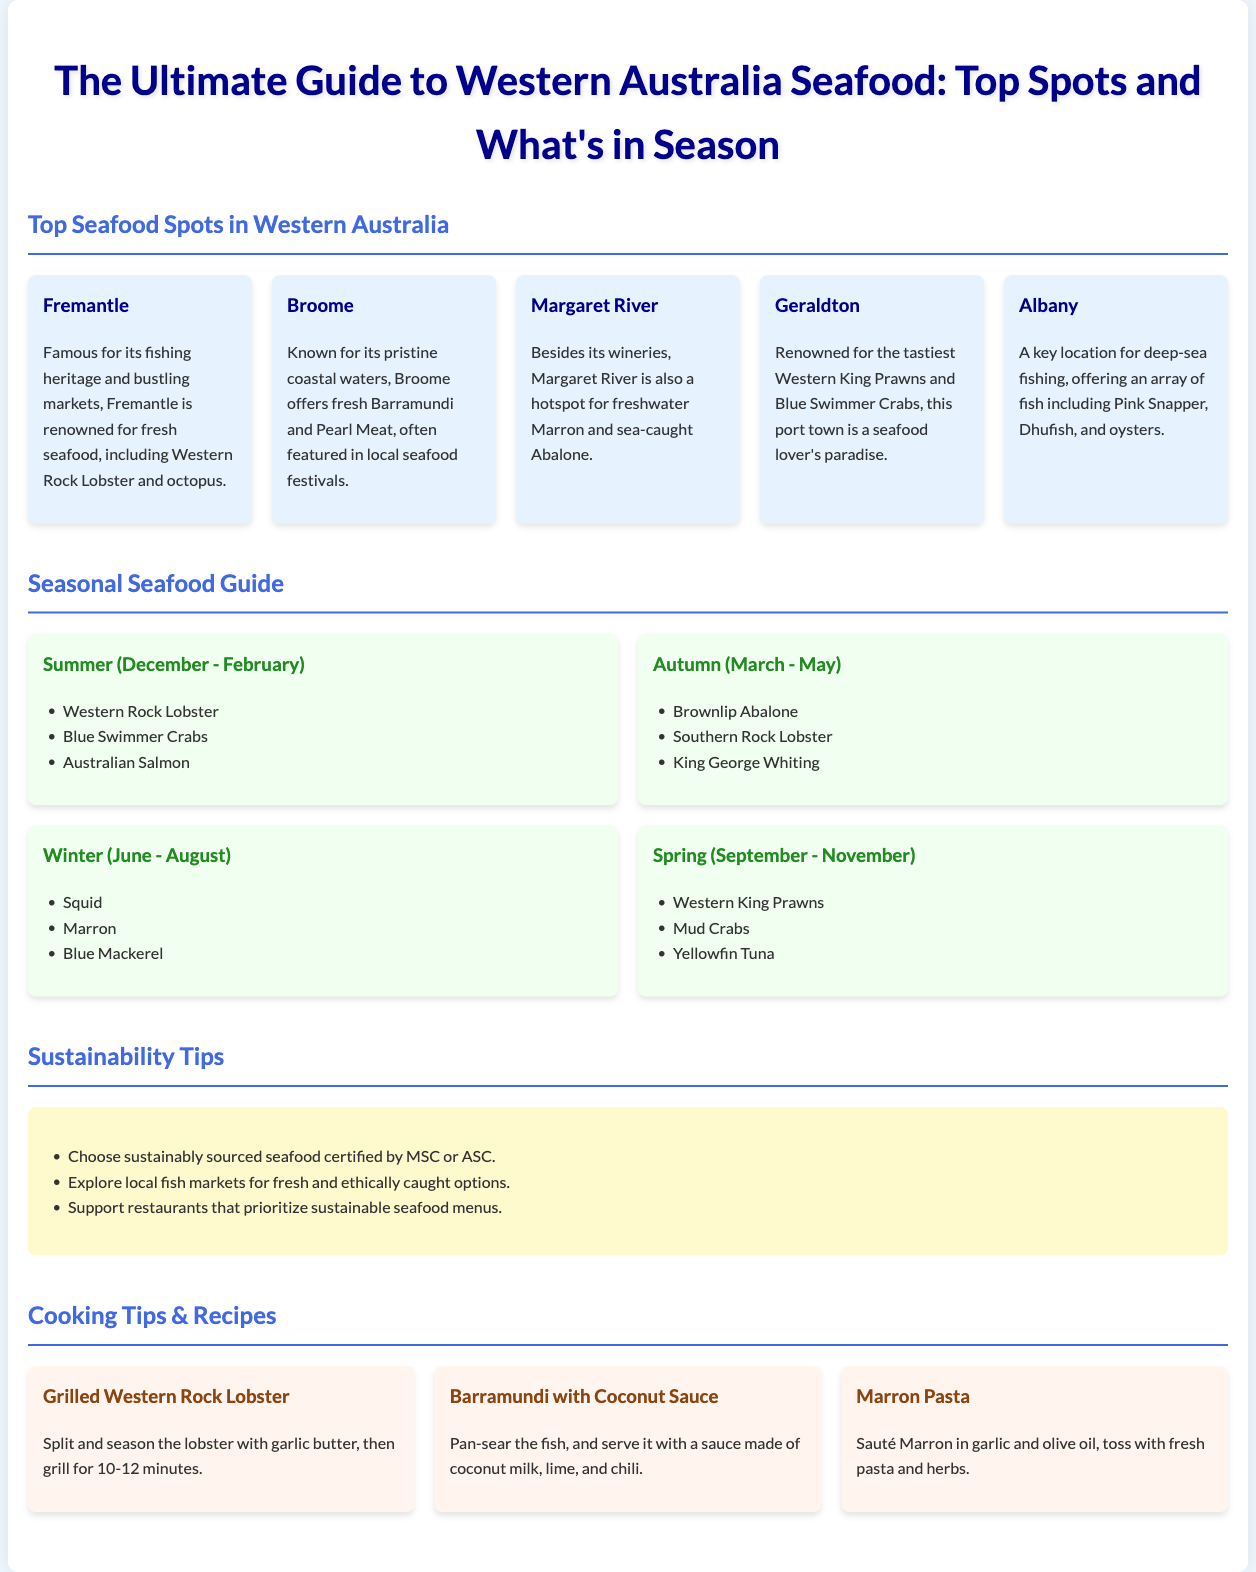What is the famous seafood in Fremantle? Fremantle is renowned for fresh seafood, including Western Rock Lobster and octopus.
Answer: Western Rock Lobster and octopus Which seafood is in season during summer? The seasonal guide lists marine options available during summer (December - February).
Answer: Western Rock Lobster What is the key location for deep-sea fishing? Albany is mentioned as a key location for deep-sea fishing in the document.
Answer: Albany What type of seafood can be caught in Broome? Broome offers fresh Barramundi and Pearl Meat, often featured in local seafood festivals.
Answer: Barramundi and Pearl Meat Which seafood is associated with autumn? The document details specific seafood available during autumn (March - May).
Answer: Brownlip Abalone What sustainability tip involves market exploration? The tips section suggests exploring local fish markets for fresh seafood.
Answer: Explore local fish markets How long should grilled Western Rock Lobster be cooked for? The cooking tip specifies the grilling time for the lobster.
Answer: 10-12 minutes What is a recommended dish that uses Marron? The recipe section provides a specific dish featuring Marron.
Answer: Marron Pasta Which town is known for the tastiest Western King Prawns? Geraldton is recognized for its tasty seafood.
Answer: Geraldton 